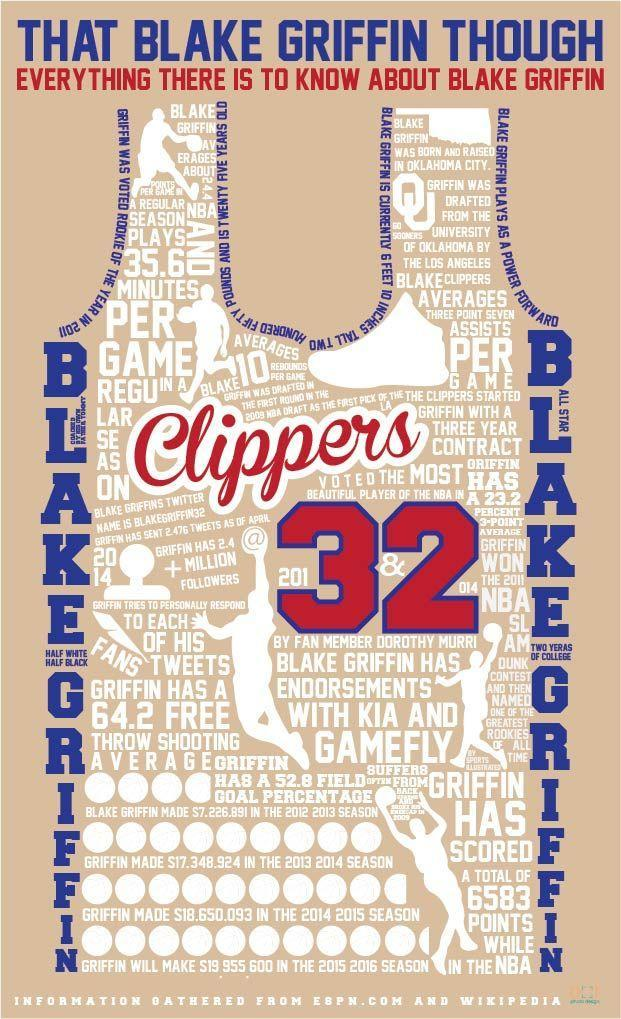What is the name of Black Griffin on Twitter?
Answer the question with a short phrase. blakegriffin32 